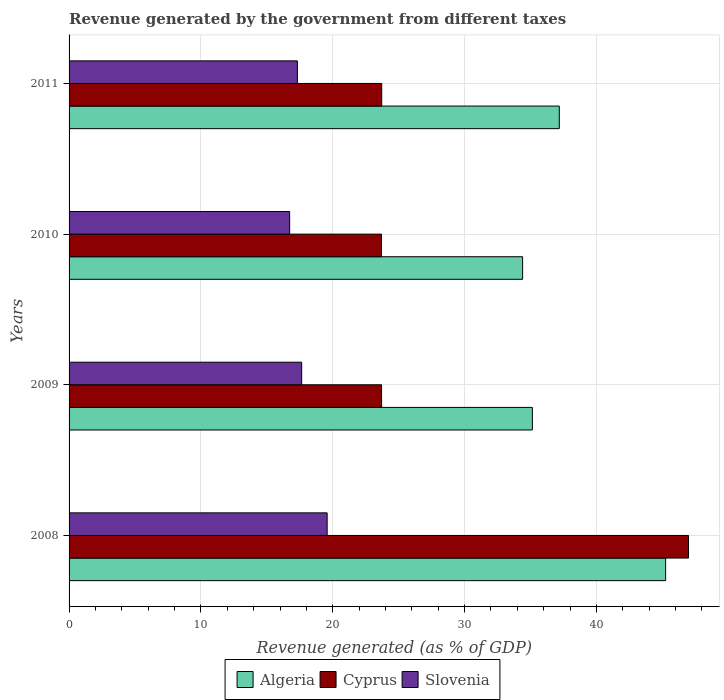How many different coloured bars are there?
Provide a short and direct response. 3. Are the number of bars per tick equal to the number of legend labels?
Give a very brief answer. Yes. How many bars are there on the 1st tick from the bottom?
Make the answer very short. 3. What is the label of the 1st group of bars from the top?
Your answer should be very brief. 2011. What is the revenue generated by the government in Cyprus in 2011?
Give a very brief answer. 23.72. Across all years, what is the maximum revenue generated by the government in Algeria?
Offer a very short reply. 45.25. Across all years, what is the minimum revenue generated by the government in Cyprus?
Your answer should be compact. 23.7. In which year was the revenue generated by the government in Cyprus maximum?
Your answer should be very brief. 2008. In which year was the revenue generated by the government in Algeria minimum?
Make the answer very short. 2010. What is the total revenue generated by the government in Algeria in the graph?
Offer a very short reply. 151.98. What is the difference between the revenue generated by the government in Algeria in 2009 and that in 2010?
Your answer should be very brief. 0.74. What is the difference between the revenue generated by the government in Cyprus in 2010 and the revenue generated by the government in Slovenia in 2011?
Ensure brevity in your answer.  6.38. What is the average revenue generated by the government in Cyprus per year?
Provide a short and direct response. 29.53. In the year 2008, what is the difference between the revenue generated by the government in Cyprus and revenue generated by the government in Slovenia?
Your answer should be very brief. 27.41. In how many years, is the revenue generated by the government in Cyprus greater than 10 %?
Your response must be concise. 4. What is the ratio of the revenue generated by the government in Cyprus in 2008 to that in 2009?
Your answer should be very brief. 1.98. Is the revenue generated by the government in Algeria in 2008 less than that in 2009?
Ensure brevity in your answer.  No. Is the difference between the revenue generated by the government in Cyprus in 2008 and 2011 greater than the difference between the revenue generated by the government in Slovenia in 2008 and 2011?
Provide a short and direct response. Yes. What is the difference between the highest and the second highest revenue generated by the government in Algeria?
Keep it short and to the point. 8.07. What is the difference between the highest and the lowest revenue generated by the government in Cyprus?
Provide a succinct answer. 23.29. Is the sum of the revenue generated by the government in Slovenia in 2008 and 2011 greater than the maximum revenue generated by the government in Algeria across all years?
Offer a terse response. No. What does the 2nd bar from the top in 2010 represents?
Provide a succinct answer. Cyprus. What does the 3rd bar from the bottom in 2011 represents?
Offer a very short reply. Slovenia. How many bars are there?
Ensure brevity in your answer.  12. Are all the bars in the graph horizontal?
Provide a succinct answer. Yes. What is the difference between two consecutive major ticks on the X-axis?
Ensure brevity in your answer.  10. Are the values on the major ticks of X-axis written in scientific E-notation?
Ensure brevity in your answer.  No. Where does the legend appear in the graph?
Ensure brevity in your answer.  Bottom center. How are the legend labels stacked?
Your answer should be compact. Horizontal. What is the title of the graph?
Your answer should be compact. Revenue generated by the government from different taxes. Does "Tunisia" appear as one of the legend labels in the graph?
Give a very brief answer. No. What is the label or title of the X-axis?
Your answer should be very brief. Revenue generated (as % of GDP). What is the Revenue generated (as % of GDP) in Algeria in 2008?
Give a very brief answer. 45.25. What is the Revenue generated (as % of GDP) in Cyprus in 2008?
Keep it short and to the point. 46.99. What is the Revenue generated (as % of GDP) in Slovenia in 2008?
Keep it short and to the point. 19.58. What is the Revenue generated (as % of GDP) of Algeria in 2009?
Ensure brevity in your answer.  35.14. What is the Revenue generated (as % of GDP) of Cyprus in 2009?
Offer a very short reply. 23.7. What is the Revenue generated (as % of GDP) in Slovenia in 2009?
Keep it short and to the point. 17.64. What is the Revenue generated (as % of GDP) of Algeria in 2010?
Provide a short and direct response. 34.4. What is the Revenue generated (as % of GDP) of Cyprus in 2010?
Provide a succinct answer. 23.7. What is the Revenue generated (as % of GDP) of Slovenia in 2010?
Give a very brief answer. 16.73. What is the Revenue generated (as % of GDP) in Algeria in 2011?
Keep it short and to the point. 37.19. What is the Revenue generated (as % of GDP) in Cyprus in 2011?
Your answer should be compact. 23.72. What is the Revenue generated (as % of GDP) of Slovenia in 2011?
Keep it short and to the point. 17.32. Across all years, what is the maximum Revenue generated (as % of GDP) in Algeria?
Offer a terse response. 45.25. Across all years, what is the maximum Revenue generated (as % of GDP) of Cyprus?
Your response must be concise. 46.99. Across all years, what is the maximum Revenue generated (as % of GDP) in Slovenia?
Offer a terse response. 19.58. Across all years, what is the minimum Revenue generated (as % of GDP) in Algeria?
Make the answer very short. 34.4. Across all years, what is the minimum Revenue generated (as % of GDP) of Cyprus?
Offer a terse response. 23.7. Across all years, what is the minimum Revenue generated (as % of GDP) in Slovenia?
Your answer should be very brief. 16.73. What is the total Revenue generated (as % of GDP) in Algeria in the graph?
Keep it short and to the point. 151.98. What is the total Revenue generated (as % of GDP) of Cyprus in the graph?
Keep it short and to the point. 118.11. What is the total Revenue generated (as % of GDP) of Slovenia in the graph?
Offer a very short reply. 71.27. What is the difference between the Revenue generated (as % of GDP) in Algeria in 2008 and that in 2009?
Provide a succinct answer. 10.11. What is the difference between the Revenue generated (as % of GDP) of Cyprus in 2008 and that in 2009?
Keep it short and to the point. 23.28. What is the difference between the Revenue generated (as % of GDP) of Slovenia in 2008 and that in 2009?
Your response must be concise. 1.93. What is the difference between the Revenue generated (as % of GDP) of Algeria in 2008 and that in 2010?
Your answer should be compact. 10.85. What is the difference between the Revenue generated (as % of GDP) in Cyprus in 2008 and that in 2010?
Make the answer very short. 23.29. What is the difference between the Revenue generated (as % of GDP) in Slovenia in 2008 and that in 2010?
Ensure brevity in your answer.  2.84. What is the difference between the Revenue generated (as % of GDP) in Algeria in 2008 and that in 2011?
Give a very brief answer. 8.07. What is the difference between the Revenue generated (as % of GDP) of Cyprus in 2008 and that in 2011?
Keep it short and to the point. 23.27. What is the difference between the Revenue generated (as % of GDP) of Slovenia in 2008 and that in 2011?
Ensure brevity in your answer.  2.26. What is the difference between the Revenue generated (as % of GDP) in Algeria in 2009 and that in 2010?
Offer a very short reply. 0.74. What is the difference between the Revenue generated (as % of GDP) in Cyprus in 2009 and that in 2010?
Keep it short and to the point. 0.01. What is the difference between the Revenue generated (as % of GDP) of Slovenia in 2009 and that in 2010?
Offer a very short reply. 0.91. What is the difference between the Revenue generated (as % of GDP) in Algeria in 2009 and that in 2011?
Keep it short and to the point. -2.04. What is the difference between the Revenue generated (as % of GDP) in Cyprus in 2009 and that in 2011?
Offer a terse response. -0.01. What is the difference between the Revenue generated (as % of GDP) of Slovenia in 2009 and that in 2011?
Your response must be concise. 0.32. What is the difference between the Revenue generated (as % of GDP) in Algeria in 2010 and that in 2011?
Your response must be concise. -2.78. What is the difference between the Revenue generated (as % of GDP) in Cyprus in 2010 and that in 2011?
Ensure brevity in your answer.  -0.02. What is the difference between the Revenue generated (as % of GDP) of Slovenia in 2010 and that in 2011?
Offer a terse response. -0.59. What is the difference between the Revenue generated (as % of GDP) in Algeria in 2008 and the Revenue generated (as % of GDP) in Cyprus in 2009?
Keep it short and to the point. 21.55. What is the difference between the Revenue generated (as % of GDP) in Algeria in 2008 and the Revenue generated (as % of GDP) in Slovenia in 2009?
Offer a terse response. 27.61. What is the difference between the Revenue generated (as % of GDP) in Cyprus in 2008 and the Revenue generated (as % of GDP) in Slovenia in 2009?
Ensure brevity in your answer.  29.34. What is the difference between the Revenue generated (as % of GDP) in Algeria in 2008 and the Revenue generated (as % of GDP) in Cyprus in 2010?
Your answer should be compact. 21.55. What is the difference between the Revenue generated (as % of GDP) of Algeria in 2008 and the Revenue generated (as % of GDP) of Slovenia in 2010?
Ensure brevity in your answer.  28.52. What is the difference between the Revenue generated (as % of GDP) in Cyprus in 2008 and the Revenue generated (as % of GDP) in Slovenia in 2010?
Your answer should be compact. 30.26. What is the difference between the Revenue generated (as % of GDP) of Algeria in 2008 and the Revenue generated (as % of GDP) of Cyprus in 2011?
Keep it short and to the point. 21.54. What is the difference between the Revenue generated (as % of GDP) of Algeria in 2008 and the Revenue generated (as % of GDP) of Slovenia in 2011?
Ensure brevity in your answer.  27.93. What is the difference between the Revenue generated (as % of GDP) in Cyprus in 2008 and the Revenue generated (as % of GDP) in Slovenia in 2011?
Your answer should be compact. 29.67. What is the difference between the Revenue generated (as % of GDP) of Algeria in 2009 and the Revenue generated (as % of GDP) of Cyprus in 2010?
Provide a short and direct response. 11.44. What is the difference between the Revenue generated (as % of GDP) of Algeria in 2009 and the Revenue generated (as % of GDP) of Slovenia in 2010?
Keep it short and to the point. 18.41. What is the difference between the Revenue generated (as % of GDP) in Cyprus in 2009 and the Revenue generated (as % of GDP) in Slovenia in 2010?
Your answer should be very brief. 6.97. What is the difference between the Revenue generated (as % of GDP) of Algeria in 2009 and the Revenue generated (as % of GDP) of Cyprus in 2011?
Offer a very short reply. 11.43. What is the difference between the Revenue generated (as % of GDP) of Algeria in 2009 and the Revenue generated (as % of GDP) of Slovenia in 2011?
Keep it short and to the point. 17.82. What is the difference between the Revenue generated (as % of GDP) in Cyprus in 2009 and the Revenue generated (as % of GDP) in Slovenia in 2011?
Offer a very short reply. 6.38. What is the difference between the Revenue generated (as % of GDP) in Algeria in 2010 and the Revenue generated (as % of GDP) in Cyprus in 2011?
Offer a terse response. 10.69. What is the difference between the Revenue generated (as % of GDP) in Algeria in 2010 and the Revenue generated (as % of GDP) in Slovenia in 2011?
Keep it short and to the point. 17.08. What is the difference between the Revenue generated (as % of GDP) in Cyprus in 2010 and the Revenue generated (as % of GDP) in Slovenia in 2011?
Your answer should be compact. 6.38. What is the average Revenue generated (as % of GDP) of Algeria per year?
Your response must be concise. 38. What is the average Revenue generated (as % of GDP) in Cyprus per year?
Your answer should be very brief. 29.53. What is the average Revenue generated (as % of GDP) in Slovenia per year?
Give a very brief answer. 17.82. In the year 2008, what is the difference between the Revenue generated (as % of GDP) in Algeria and Revenue generated (as % of GDP) in Cyprus?
Keep it short and to the point. -1.74. In the year 2008, what is the difference between the Revenue generated (as % of GDP) of Algeria and Revenue generated (as % of GDP) of Slovenia?
Your answer should be compact. 25.68. In the year 2008, what is the difference between the Revenue generated (as % of GDP) in Cyprus and Revenue generated (as % of GDP) in Slovenia?
Offer a terse response. 27.41. In the year 2009, what is the difference between the Revenue generated (as % of GDP) in Algeria and Revenue generated (as % of GDP) in Cyprus?
Your answer should be very brief. 11.44. In the year 2009, what is the difference between the Revenue generated (as % of GDP) of Algeria and Revenue generated (as % of GDP) of Slovenia?
Give a very brief answer. 17.5. In the year 2009, what is the difference between the Revenue generated (as % of GDP) in Cyprus and Revenue generated (as % of GDP) in Slovenia?
Ensure brevity in your answer.  6.06. In the year 2010, what is the difference between the Revenue generated (as % of GDP) in Algeria and Revenue generated (as % of GDP) in Cyprus?
Give a very brief answer. 10.7. In the year 2010, what is the difference between the Revenue generated (as % of GDP) in Algeria and Revenue generated (as % of GDP) in Slovenia?
Provide a short and direct response. 17.67. In the year 2010, what is the difference between the Revenue generated (as % of GDP) of Cyprus and Revenue generated (as % of GDP) of Slovenia?
Ensure brevity in your answer.  6.97. In the year 2011, what is the difference between the Revenue generated (as % of GDP) in Algeria and Revenue generated (as % of GDP) in Cyprus?
Offer a very short reply. 13.47. In the year 2011, what is the difference between the Revenue generated (as % of GDP) of Algeria and Revenue generated (as % of GDP) of Slovenia?
Your answer should be very brief. 19.86. In the year 2011, what is the difference between the Revenue generated (as % of GDP) in Cyprus and Revenue generated (as % of GDP) in Slovenia?
Give a very brief answer. 6.39. What is the ratio of the Revenue generated (as % of GDP) in Algeria in 2008 to that in 2009?
Give a very brief answer. 1.29. What is the ratio of the Revenue generated (as % of GDP) in Cyprus in 2008 to that in 2009?
Your answer should be compact. 1.98. What is the ratio of the Revenue generated (as % of GDP) of Slovenia in 2008 to that in 2009?
Your response must be concise. 1.11. What is the ratio of the Revenue generated (as % of GDP) of Algeria in 2008 to that in 2010?
Provide a short and direct response. 1.32. What is the ratio of the Revenue generated (as % of GDP) of Cyprus in 2008 to that in 2010?
Make the answer very short. 1.98. What is the ratio of the Revenue generated (as % of GDP) in Slovenia in 2008 to that in 2010?
Make the answer very short. 1.17. What is the ratio of the Revenue generated (as % of GDP) of Algeria in 2008 to that in 2011?
Your answer should be compact. 1.22. What is the ratio of the Revenue generated (as % of GDP) in Cyprus in 2008 to that in 2011?
Keep it short and to the point. 1.98. What is the ratio of the Revenue generated (as % of GDP) in Slovenia in 2008 to that in 2011?
Your response must be concise. 1.13. What is the ratio of the Revenue generated (as % of GDP) in Algeria in 2009 to that in 2010?
Your answer should be compact. 1.02. What is the ratio of the Revenue generated (as % of GDP) in Cyprus in 2009 to that in 2010?
Your answer should be very brief. 1. What is the ratio of the Revenue generated (as % of GDP) of Slovenia in 2009 to that in 2010?
Your response must be concise. 1.05. What is the ratio of the Revenue generated (as % of GDP) of Algeria in 2009 to that in 2011?
Provide a short and direct response. 0.95. What is the ratio of the Revenue generated (as % of GDP) in Slovenia in 2009 to that in 2011?
Provide a short and direct response. 1.02. What is the ratio of the Revenue generated (as % of GDP) of Algeria in 2010 to that in 2011?
Give a very brief answer. 0.93. What is the difference between the highest and the second highest Revenue generated (as % of GDP) of Algeria?
Offer a terse response. 8.07. What is the difference between the highest and the second highest Revenue generated (as % of GDP) of Cyprus?
Your answer should be compact. 23.27. What is the difference between the highest and the second highest Revenue generated (as % of GDP) in Slovenia?
Your answer should be very brief. 1.93. What is the difference between the highest and the lowest Revenue generated (as % of GDP) of Algeria?
Your answer should be compact. 10.85. What is the difference between the highest and the lowest Revenue generated (as % of GDP) in Cyprus?
Make the answer very short. 23.29. What is the difference between the highest and the lowest Revenue generated (as % of GDP) in Slovenia?
Offer a terse response. 2.84. 